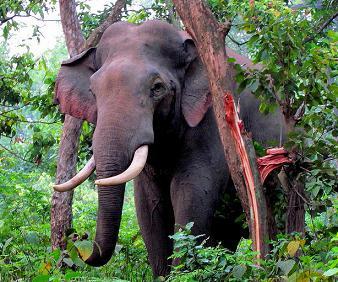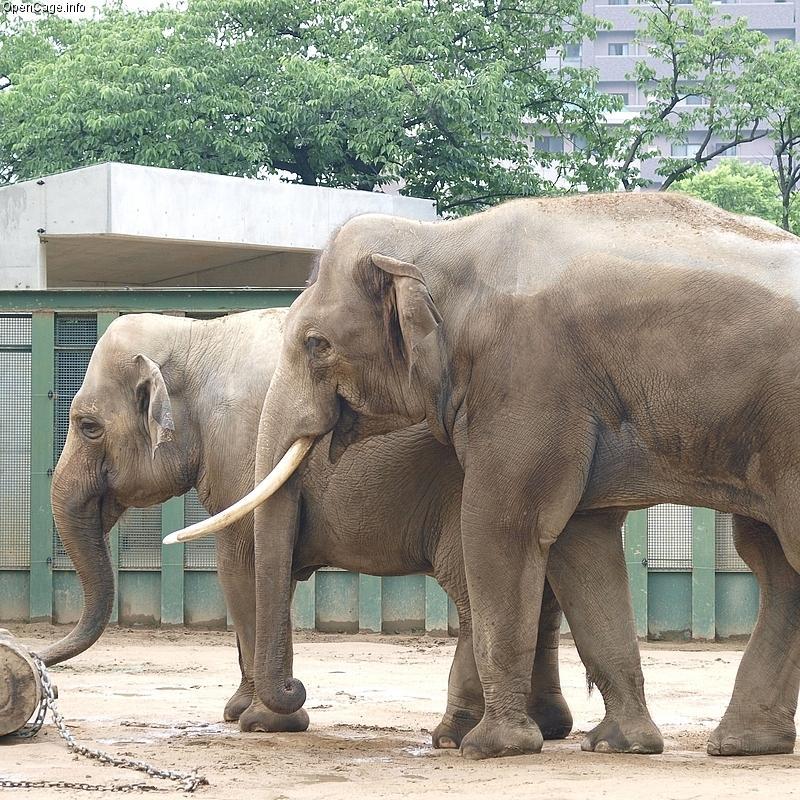The first image is the image on the left, the second image is the image on the right. For the images displayed, is the sentence "Only one image includes an elephant with prominent tusks." factually correct? Answer yes or no. No. The first image is the image on the left, the second image is the image on the right. Examine the images to the left and right. Is the description "One of the elephants is near an area of water." accurate? Answer yes or no. No. 